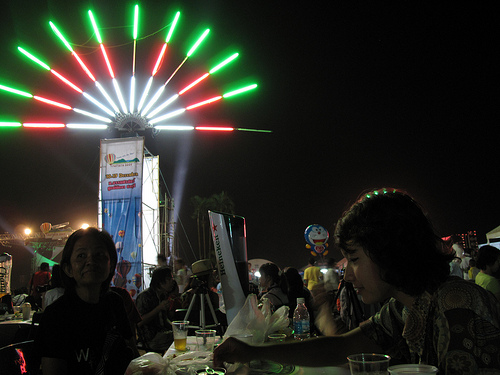<image>
Is the light in front of the person? No. The light is not in front of the person. The spatial positioning shows a different relationship between these objects. 